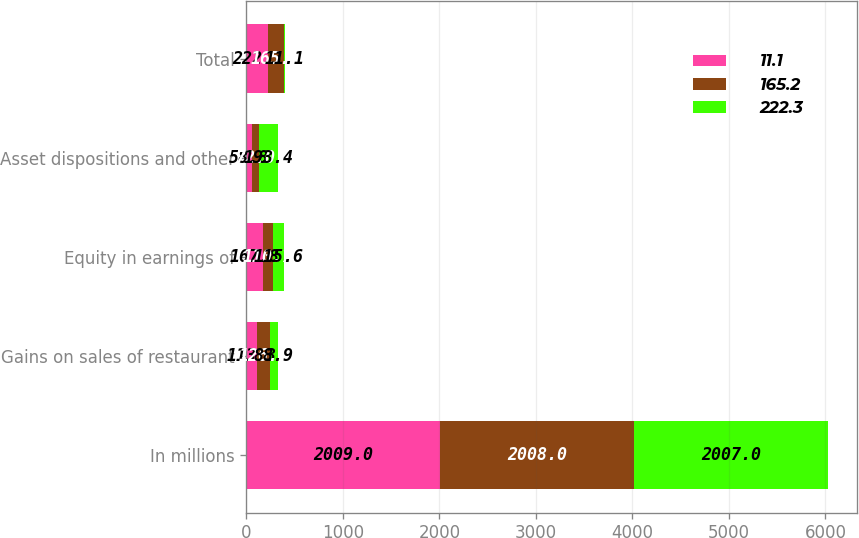Convert chart to OTSL. <chart><loc_0><loc_0><loc_500><loc_500><stacked_bar_chart><ecel><fcel>In millions<fcel>Gains on sales of restaurant<fcel>Equity in earnings of<fcel>Asset dispositions and other<fcel>Total<nl><fcel>11.1<fcel>2009<fcel>113.3<fcel>167.8<fcel>58.8<fcel>222.3<nl><fcel>165.2<fcel>2008<fcel>126.5<fcel>110.7<fcel>72<fcel>165.2<nl><fcel>222.3<fcel>2007<fcel>88.9<fcel>115.6<fcel>193.4<fcel>11.1<nl></chart> 